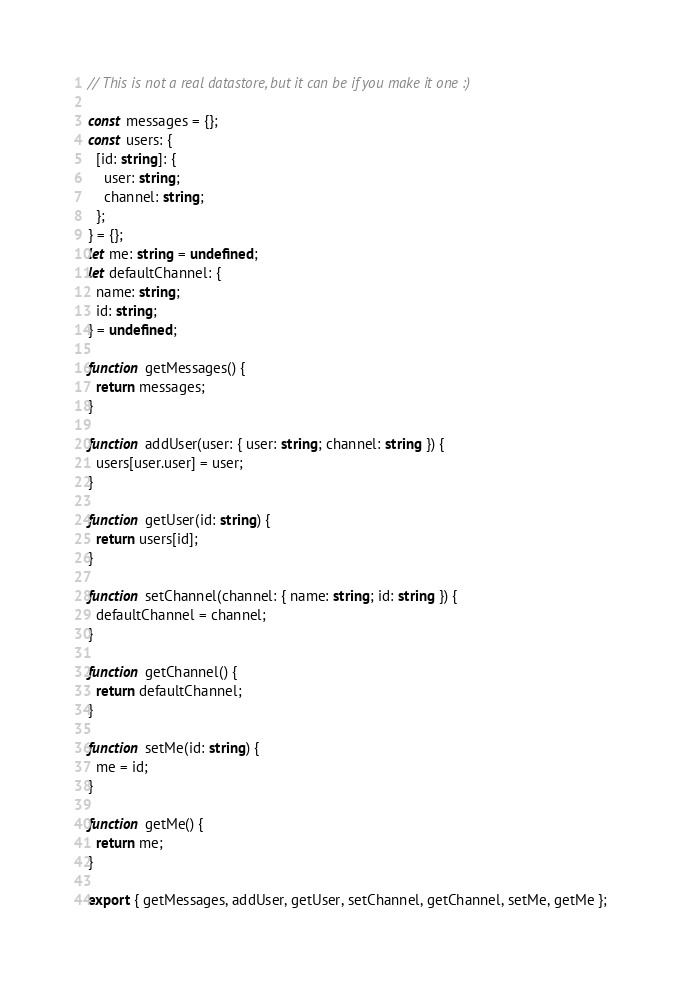<code> <loc_0><loc_0><loc_500><loc_500><_TypeScript_>// This is not a real datastore, but it can be if you make it one :)

const messages = {};
const users: {
  [id: string]: {
    user: string;
    channel: string;
  };
} = {};
let me: string = undefined;
let defaultChannel: {
  name: string;
  id: string;
} = undefined;

function getMessages() {
  return messages;
}

function addUser(user: { user: string; channel: string }) {
  users[user.user] = user;
}

function getUser(id: string) {
  return users[id];
}

function setChannel(channel: { name: string; id: string }) {
  defaultChannel = channel;
}

function getChannel() {
  return defaultChannel;
}

function setMe(id: string) {
  me = id;
}

function getMe() {
  return me;
}

export { getMessages, addUser, getUser, setChannel, getChannel, setMe, getMe };
</code> 